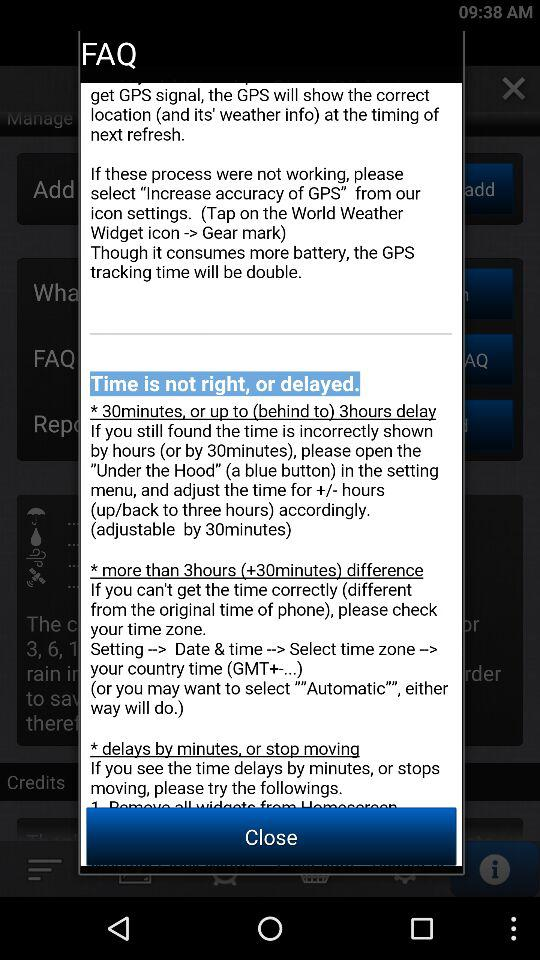What to do if the time is 30 minutes or upto 3 hours delay? If the time is 30 minutes or upto 3 hours delay, please open "Under the Hood" (a blue button) in the setting menu and adjust the time for +/- hours (up/back to three hours) accordingly. 